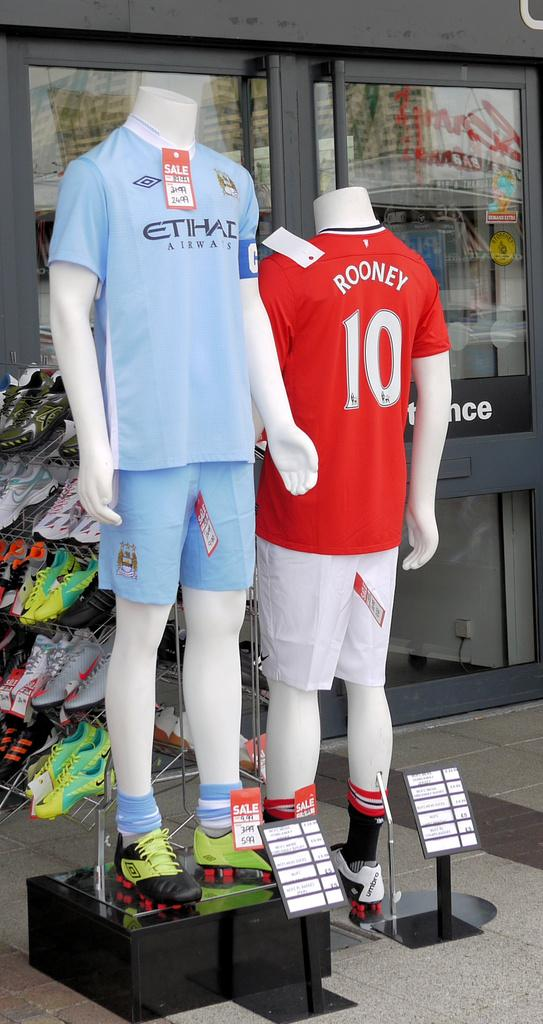<image>
Provide a brief description of the given image. A manikin with a red Rooney shirt on it. 